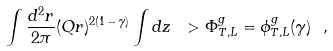Convert formula to latex. <formula><loc_0><loc_0><loc_500><loc_500>\int \frac { d ^ { 2 } r } { 2 \pi } ( Q r ) ^ { 2 ( 1 \, - \, \gamma ) } \int d z \ > \Phi ^ { g } _ { T , L } = \phi ^ { g } _ { T , L } ( \gamma ) \ ,</formula> 